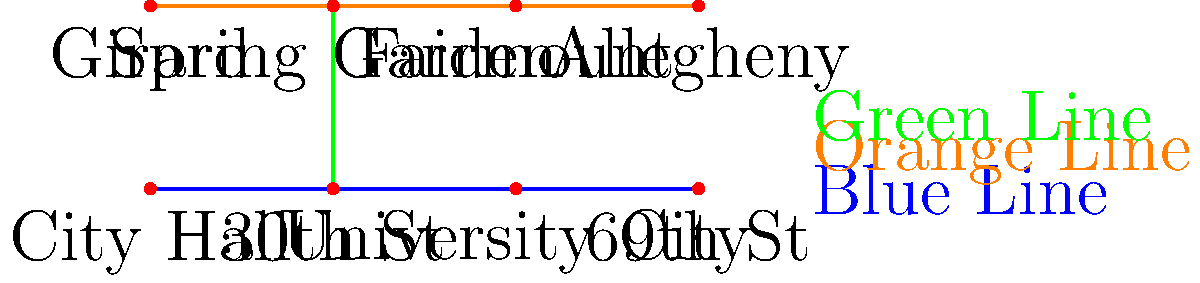Based on the simplified map of Philadelphia's public transportation system, how many transfers would be required to travel from 69th St station to Allegheny station using the most efficient route? To determine the most efficient route from 69th St station to Allegheny station, let's follow these steps:

1. Identify the starting point: 69th St station on the Blue Line.
2. Identify the destination: Allegheny station on the Orange Line.
3. Analyze the map for possible routes:
   a. Blue Line goes from 69th St to City Hall.
   b. Green Line connects Blue and Orange Lines at 30th St and Spring Garden.
4. The most efficient route would be:
   a. Take the Blue Line from 69th St to 30th St (1 segment).
   b. Transfer to the Green Line at 30th St (1st transfer).
   c. Take the Green Line from 30th St to Spring Garden (1 segment).
   d. Transfer to the Orange Line at Spring Garden (2nd transfer).
   e. Take the Orange Line from Spring Garden to Allegheny (1 segment).
5. Count the number of transfers: 2 transfers are required (Blue to Green, Green to Orange).

This route minimizes the number of transfers while efficiently reaching the destination.
Answer: 2 transfers 